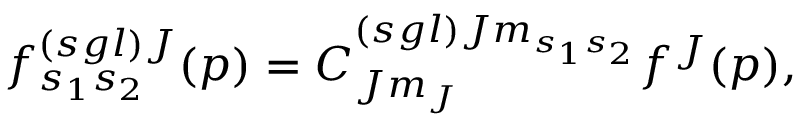<formula> <loc_0><loc_0><loc_500><loc_500>f _ { s _ { 1 } s _ { 2 } } ^ { \left ( s g l \right ) J } ( p ) = C _ { J m _ { J } } ^ { \left ( s g l \right ) J m _ { s _ { 1 } s _ { 2 } } } f ^ { J } ( p ) ,</formula> 